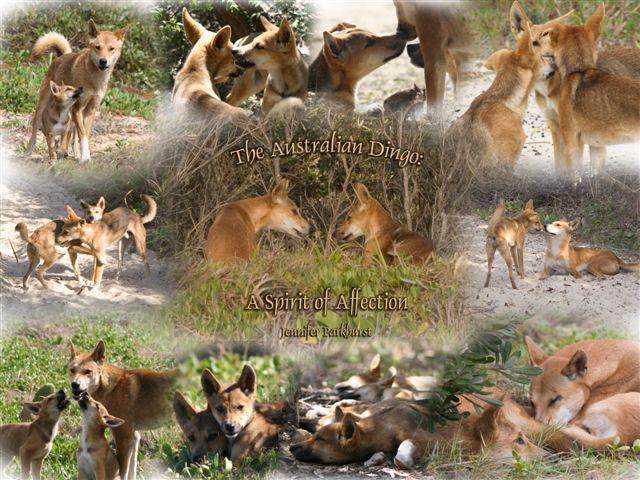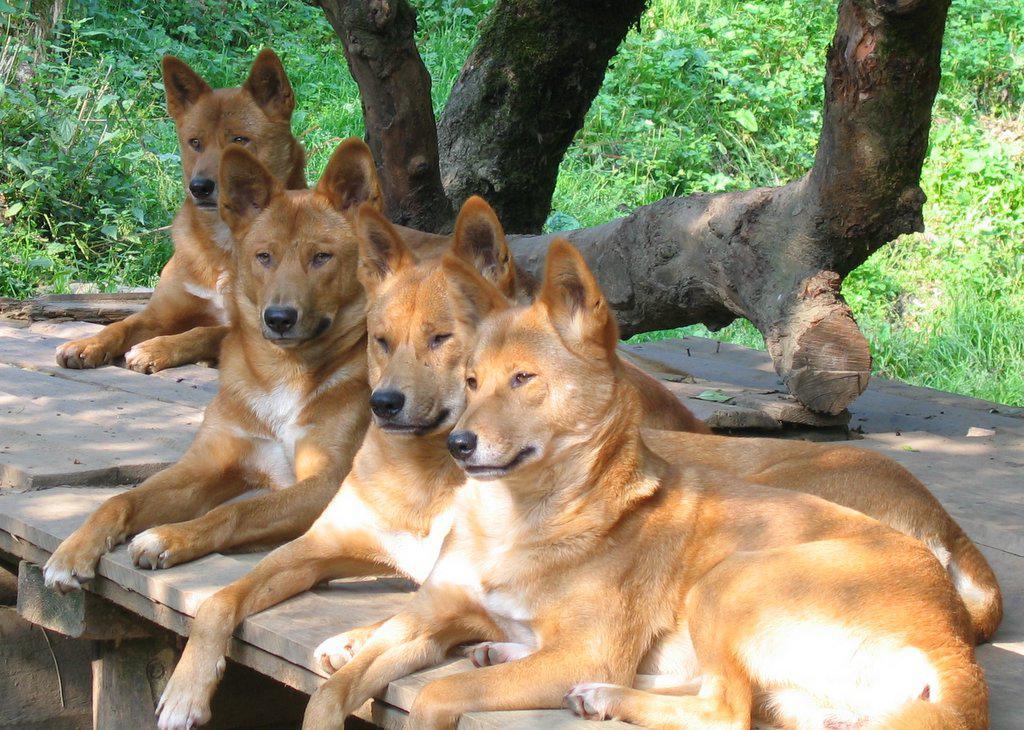The first image is the image on the left, the second image is the image on the right. For the images shown, is this caption "None of the animals are lying down." true? Answer yes or no. No. The first image is the image on the left, the second image is the image on the right. For the images displayed, is the sentence "There are 3 dogs in one of the images." factually correct? Answer yes or no. No. 